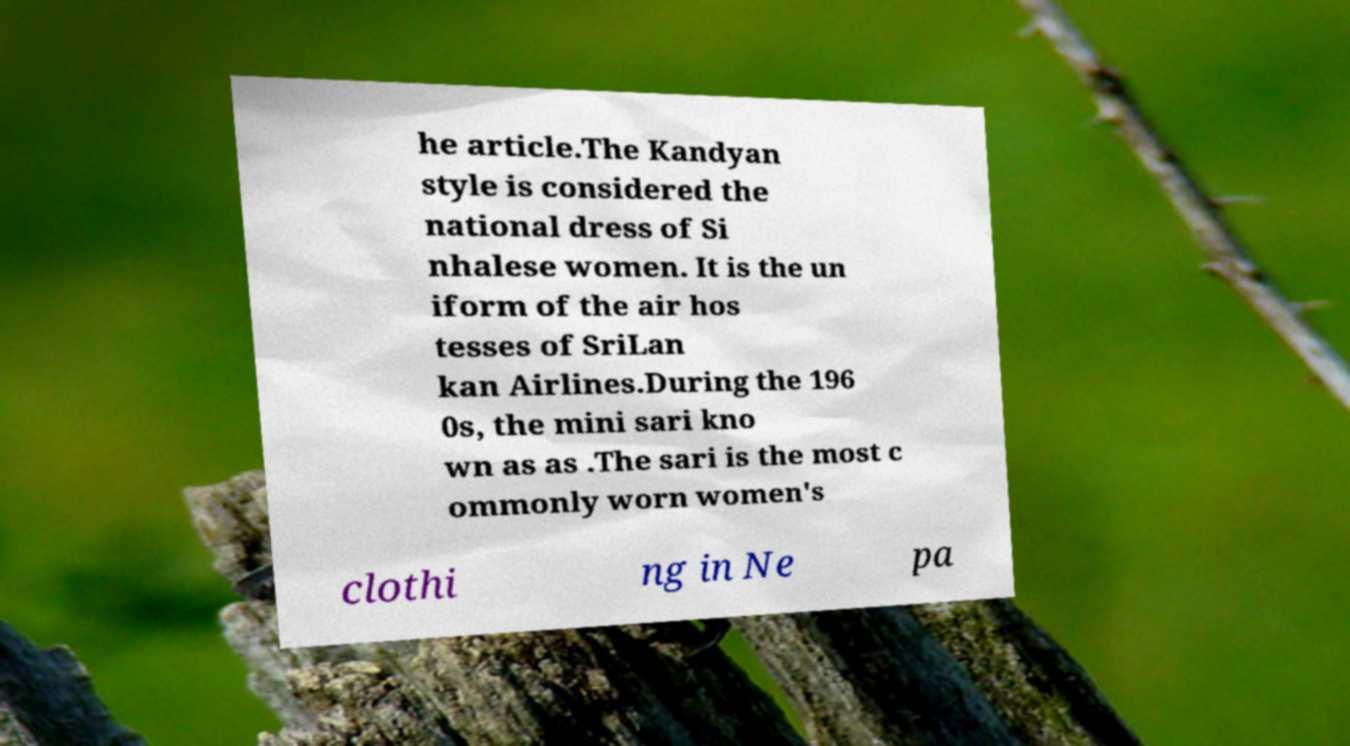Can you accurately transcribe the text from the provided image for me? he article.The Kandyan style is considered the national dress of Si nhalese women. It is the un iform of the air hos tesses of SriLan kan Airlines.During the 196 0s, the mini sari kno wn as as .The sari is the most c ommonly worn women's clothi ng in Ne pa 